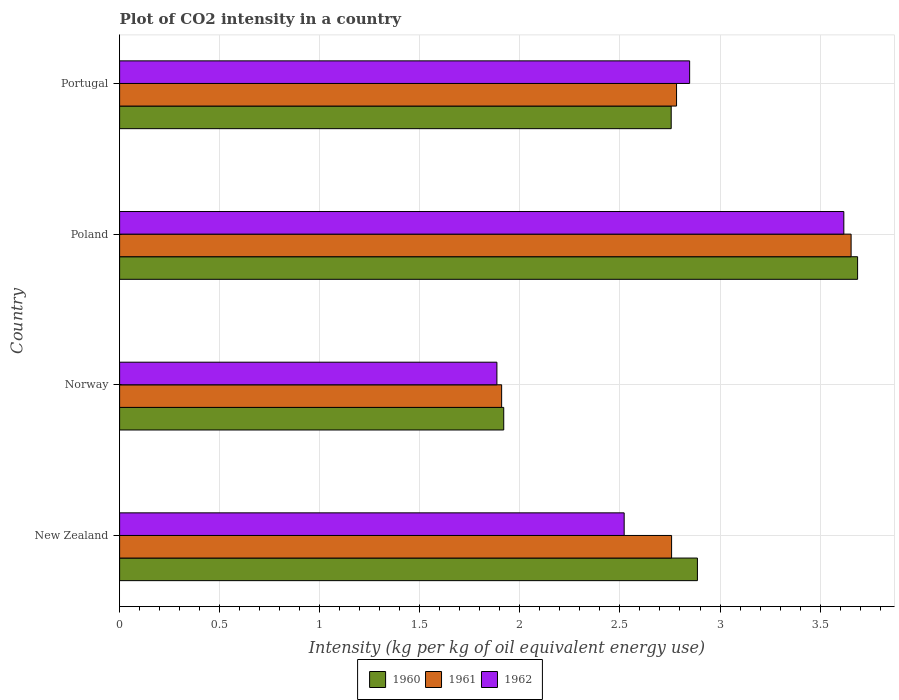How many groups of bars are there?
Ensure brevity in your answer.  4. Are the number of bars per tick equal to the number of legend labels?
Your answer should be compact. Yes. How many bars are there on the 3rd tick from the top?
Make the answer very short. 3. How many bars are there on the 3rd tick from the bottom?
Ensure brevity in your answer.  3. What is the label of the 4th group of bars from the top?
Your response must be concise. New Zealand. What is the CO2 intensity in in 1962 in Norway?
Keep it short and to the point. 1.89. Across all countries, what is the maximum CO2 intensity in in 1961?
Make the answer very short. 3.66. Across all countries, what is the minimum CO2 intensity in in 1961?
Provide a short and direct response. 1.91. In which country was the CO2 intensity in in 1962 maximum?
Your response must be concise. Poland. What is the total CO2 intensity in in 1961 in the graph?
Offer a terse response. 11.1. What is the difference between the CO2 intensity in in 1961 in Norway and that in Poland?
Provide a short and direct response. -1.75. What is the difference between the CO2 intensity in in 1962 in Poland and the CO2 intensity in in 1961 in Portugal?
Offer a very short reply. 0.84. What is the average CO2 intensity in in 1960 per country?
Your answer should be compact. 2.81. What is the difference between the CO2 intensity in in 1960 and CO2 intensity in in 1961 in Norway?
Offer a terse response. 0.01. In how many countries, is the CO2 intensity in in 1960 greater than 2.3 kg?
Keep it short and to the point. 3. What is the ratio of the CO2 intensity in in 1962 in New Zealand to that in Norway?
Provide a short and direct response. 1.34. Is the CO2 intensity in in 1962 in Norway less than that in Poland?
Keep it short and to the point. Yes. What is the difference between the highest and the second highest CO2 intensity in in 1960?
Offer a terse response. 0.8. What is the difference between the highest and the lowest CO2 intensity in in 1961?
Offer a terse response. 1.75. How many bars are there?
Provide a succinct answer. 12. Are all the bars in the graph horizontal?
Offer a very short reply. Yes. How many countries are there in the graph?
Keep it short and to the point. 4. Are the values on the major ticks of X-axis written in scientific E-notation?
Your response must be concise. No. Does the graph contain any zero values?
Make the answer very short. No. Does the graph contain grids?
Make the answer very short. Yes. How are the legend labels stacked?
Your answer should be compact. Horizontal. What is the title of the graph?
Provide a short and direct response. Plot of CO2 intensity in a country. Does "1984" appear as one of the legend labels in the graph?
Ensure brevity in your answer.  No. What is the label or title of the X-axis?
Provide a succinct answer. Intensity (kg per kg of oil equivalent energy use). What is the label or title of the Y-axis?
Offer a terse response. Country. What is the Intensity (kg per kg of oil equivalent energy use) of 1960 in New Zealand?
Offer a terse response. 2.89. What is the Intensity (kg per kg of oil equivalent energy use) of 1961 in New Zealand?
Provide a succinct answer. 2.76. What is the Intensity (kg per kg of oil equivalent energy use) of 1962 in New Zealand?
Your answer should be compact. 2.52. What is the Intensity (kg per kg of oil equivalent energy use) in 1960 in Norway?
Your answer should be compact. 1.92. What is the Intensity (kg per kg of oil equivalent energy use) of 1961 in Norway?
Ensure brevity in your answer.  1.91. What is the Intensity (kg per kg of oil equivalent energy use) in 1962 in Norway?
Offer a very short reply. 1.89. What is the Intensity (kg per kg of oil equivalent energy use) of 1960 in Poland?
Your answer should be very brief. 3.69. What is the Intensity (kg per kg of oil equivalent energy use) in 1961 in Poland?
Ensure brevity in your answer.  3.66. What is the Intensity (kg per kg of oil equivalent energy use) of 1962 in Poland?
Offer a terse response. 3.62. What is the Intensity (kg per kg of oil equivalent energy use) in 1960 in Portugal?
Give a very brief answer. 2.76. What is the Intensity (kg per kg of oil equivalent energy use) in 1961 in Portugal?
Your answer should be very brief. 2.78. What is the Intensity (kg per kg of oil equivalent energy use) of 1962 in Portugal?
Your answer should be compact. 2.85. Across all countries, what is the maximum Intensity (kg per kg of oil equivalent energy use) of 1960?
Make the answer very short. 3.69. Across all countries, what is the maximum Intensity (kg per kg of oil equivalent energy use) in 1961?
Offer a terse response. 3.66. Across all countries, what is the maximum Intensity (kg per kg of oil equivalent energy use) in 1962?
Your response must be concise. 3.62. Across all countries, what is the minimum Intensity (kg per kg of oil equivalent energy use) in 1960?
Your response must be concise. 1.92. Across all countries, what is the minimum Intensity (kg per kg of oil equivalent energy use) of 1961?
Provide a succinct answer. 1.91. Across all countries, what is the minimum Intensity (kg per kg of oil equivalent energy use) of 1962?
Keep it short and to the point. 1.89. What is the total Intensity (kg per kg of oil equivalent energy use) of 1960 in the graph?
Provide a short and direct response. 11.25. What is the total Intensity (kg per kg of oil equivalent energy use) in 1961 in the graph?
Provide a short and direct response. 11.1. What is the total Intensity (kg per kg of oil equivalent energy use) of 1962 in the graph?
Keep it short and to the point. 10.87. What is the difference between the Intensity (kg per kg of oil equivalent energy use) of 1960 in New Zealand and that in Norway?
Keep it short and to the point. 0.97. What is the difference between the Intensity (kg per kg of oil equivalent energy use) in 1961 in New Zealand and that in Norway?
Your answer should be compact. 0.85. What is the difference between the Intensity (kg per kg of oil equivalent energy use) in 1962 in New Zealand and that in Norway?
Your response must be concise. 0.64. What is the difference between the Intensity (kg per kg of oil equivalent energy use) of 1960 in New Zealand and that in Poland?
Ensure brevity in your answer.  -0.8. What is the difference between the Intensity (kg per kg of oil equivalent energy use) of 1961 in New Zealand and that in Poland?
Offer a terse response. -0.9. What is the difference between the Intensity (kg per kg of oil equivalent energy use) in 1962 in New Zealand and that in Poland?
Your answer should be compact. -1.1. What is the difference between the Intensity (kg per kg of oil equivalent energy use) in 1960 in New Zealand and that in Portugal?
Provide a succinct answer. 0.13. What is the difference between the Intensity (kg per kg of oil equivalent energy use) of 1961 in New Zealand and that in Portugal?
Make the answer very short. -0.02. What is the difference between the Intensity (kg per kg of oil equivalent energy use) of 1962 in New Zealand and that in Portugal?
Your response must be concise. -0.33. What is the difference between the Intensity (kg per kg of oil equivalent energy use) in 1960 in Norway and that in Poland?
Offer a terse response. -1.77. What is the difference between the Intensity (kg per kg of oil equivalent energy use) in 1961 in Norway and that in Poland?
Ensure brevity in your answer.  -1.75. What is the difference between the Intensity (kg per kg of oil equivalent energy use) of 1962 in Norway and that in Poland?
Keep it short and to the point. -1.73. What is the difference between the Intensity (kg per kg of oil equivalent energy use) in 1960 in Norway and that in Portugal?
Provide a succinct answer. -0.84. What is the difference between the Intensity (kg per kg of oil equivalent energy use) of 1961 in Norway and that in Portugal?
Your response must be concise. -0.87. What is the difference between the Intensity (kg per kg of oil equivalent energy use) in 1962 in Norway and that in Portugal?
Provide a succinct answer. -0.96. What is the difference between the Intensity (kg per kg of oil equivalent energy use) in 1960 in Poland and that in Portugal?
Offer a terse response. 0.93. What is the difference between the Intensity (kg per kg of oil equivalent energy use) in 1961 in Poland and that in Portugal?
Keep it short and to the point. 0.87. What is the difference between the Intensity (kg per kg of oil equivalent energy use) of 1962 in Poland and that in Portugal?
Make the answer very short. 0.77. What is the difference between the Intensity (kg per kg of oil equivalent energy use) in 1960 in New Zealand and the Intensity (kg per kg of oil equivalent energy use) in 1961 in Norway?
Provide a succinct answer. 0.98. What is the difference between the Intensity (kg per kg of oil equivalent energy use) of 1961 in New Zealand and the Intensity (kg per kg of oil equivalent energy use) of 1962 in Norway?
Keep it short and to the point. 0.87. What is the difference between the Intensity (kg per kg of oil equivalent energy use) in 1960 in New Zealand and the Intensity (kg per kg of oil equivalent energy use) in 1961 in Poland?
Your response must be concise. -0.77. What is the difference between the Intensity (kg per kg of oil equivalent energy use) of 1960 in New Zealand and the Intensity (kg per kg of oil equivalent energy use) of 1962 in Poland?
Keep it short and to the point. -0.73. What is the difference between the Intensity (kg per kg of oil equivalent energy use) in 1961 in New Zealand and the Intensity (kg per kg of oil equivalent energy use) in 1962 in Poland?
Your response must be concise. -0.86. What is the difference between the Intensity (kg per kg of oil equivalent energy use) in 1960 in New Zealand and the Intensity (kg per kg of oil equivalent energy use) in 1961 in Portugal?
Provide a short and direct response. 0.1. What is the difference between the Intensity (kg per kg of oil equivalent energy use) in 1960 in New Zealand and the Intensity (kg per kg of oil equivalent energy use) in 1962 in Portugal?
Ensure brevity in your answer.  0.04. What is the difference between the Intensity (kg per kg of oil equivalent energy use) in 1961 in New Zealand and the Intensity (kg per kg of oil equivalent energy use) in 1962 in Portugal?
Provide a short and direct response. -0.09. What is the difference between the Intensity (kg per kg of oil equivalent energy use) in 1960 in Norway and the Intensity (kg per kg of oil equivalent energy use) in 1961 in Poland?
Offer a very short reply. -1.74. What is the difference between the Intensity (kg per kg of oil equivalent energy use) of 1960 in Norway and the Intensity (kg per kg of oil equivalent energy use) of 1962 in Poland?
Provide a short and direct response. -1.7. What is the difference between the Intensity (kg per kg of oil equivalent energy use) of 1961 in Norway and the Intensity (kg per kg of oil equivalent energy use) of 1962 in Poland?
Your answer should be very brief. -1.71. What is the difference between the Intensity (kg per kg of oil equivalent energy use) in 1960 in Norway and the Intensity (kg per kg of oil equivalent energy use) in 1961 in Portugal?
Your answer should be very brief. -0.86. What is the difference between the Intensity (kg per kg of oil equivalent energy use) of 1960 in Norway and the Intensity (kg per kg of oil equivalent energy use) of 1962 in Portugal?
Your answer should be compact. -0.93. What is the difference between the Intensity (kg per kg of oil equivalent energy use) of 1961 in Norway and the Intensity (kg per kg of oil equivalent energy use) of 1962 in Portugal?
Provide a short and direct response. -0.94. What is the difference between the Intensity (kg per kg of oil equivalent energy use) in 1960 in Poland and the Intensity (kg per kg of oil equivalent energy use) in 1961 in Portugal?
Ensure brevity in your answer.  0.9. What is the difference between the Intensity (kg per kg of oil equivalent energy use) in 1960 in Poland and the Intensity (kg per kg of oil equivalent energy use) in 1962 in Portugal?
Offer a terse response. 0.84. What is the difference between the Intensity (kg per kg of oil equivalent energy use) in 1961 in Poland and the Intensity (kg per kg of oil equivalent energy use) in 1962 in Portugal?
Keep it short and to the point. 0.81. What is the average Intensity (kg per kg of oil equivalent energy use) in 1960 per country?
Your response must be concise. 2.81. What is the average Intensity (kg per kg of oil equivalent energy use) in 1961 per country?
Your answer should be very brief. 2.78. What is the average Intensity (kg per kg of oil equivalent energy use) of 1962 per country?
Give a very brief answer. 2.72. What is the difference between the Intensity (kg per kg of oil equivalent energy use) of 1960 and Intensity (kg per kg of oil equivalent energy use) of 1961 in New Zealand?
Provide a short and direct response. 0.13. What is the difference between the Intensity (kg per kg of oil equivalent energy use) in 1960 and Intensity (kg per kg of oil equivalent energy use) in 1962 in New Zealand?
Make the answer very short. 0.37. What is the difference between the Intensity (kg per kg of oil equivalent energy use) in 1961 and Intensity (kg per kg of oil equivalent energy use) in 1962 in New Zealand?
Your answer should be compact. 0.24. What is the difference between the Intensity (kg per kg of oil equivalent energy use) in 1960 and Intensity (kg per kg of oil equivalent energy use) in 1961 in Norway?
Offer a very short reply. 0.01. What is the difference between the Intensity (kg per kg of oil equivalent energy use) of 1960 and Intensity (kg per kg of oil equivalent energy use) of 1962 in Norway?
Provide a succinct answer. 0.03. What is the difference between the Intensity (kg per kg of oil equivalent energy use) of 1961 and Intensity (kg per kg of oil equivalent energy use) of 1962 in Norway?
Provide a short and direct response. 0.02. What is the difference between the Intensity (kg per kg of oil equivalent energy use) in 1960 and Intensity (kg per kg of oil equivalent energy use) in 1961 in Poland?
Offer a terse response. 0.03. What is the difference between the Intensity (kg per kg of oil equivalent energy use) in 1960 and Intensity (kg per kg of oil equivalent energy use) in 1962 in Poland?
Make the answer very short. 0.07. What is the difference between the Intensity (kg per kg of oil equivalent energy use) in 1961 and Intensity (kg per kg of oil equivalent energy use) in 1962 in Poland?
Provide a short and direct response. 0.04. What is the difference between the Intensity (kg per kg of oil equivalent energy use) of 1960 and Intensity (kg per kg of oil equivalent energy use) of 1961 in Portugal?
Provide a succinct answer. -0.03. What is the difference between the Intensity (kg per kg of oil equivalent energy use) in 1960 and Intensity (kg per kg of oil equivalent energy use) in 1962 in Portugal?
Offer a terse response. -0.09. What is the difference between the Intensity (kg per kg of oil equivalent energy use) in 1961 and Intensity (kg per kg of oil equivalent energy use) in 1962 in Portugal?
Your answer should be very brief. -0.07. What is the ratio of the Intensity (kg per kg of oil equivalent energy use) in 1960 in New Zealand to that in Norway?
Your response must be concise. 1.5. What is the ratio of the Intensity (kg per kg of oil equivalent energy use) in 1961 in New Zealand to that in Norway?
Offer a very short reply. 1.44. What is the ratio of the Intensity (kg per kg of oil equivalent energy use) in 1962 in New Zealand to that in Norway?
Give a very brief answer. 1.34. What is the ratio of the Intensity (kg per kg of oil equivalent energy use) of 1960 in New Zealand to that in Poland?
Your response must be concise. 0.78. What is the ratio of the Intensity (kg per kg of oil equivalent energy use) of 1961 in New Zealand to that in Poland?
Keep it short and to the point. 0.75. What is the ratio of the Intensity (kg per kg of oil equivalent energy use) of 1962 in New Zealand to that in Poland?
Provide a succinct answer. 0.7. What is the ratio of the Intensity (kg per kg of oil equivalent energy use) in 1960 in New Zealand to that in Portugal?
Offer a very short reply. 1.05. What is the ratio of the Intensity (kg per kg of oil equivalent energy use) in 1961 in New Zealand to that in Portugal?
Provide a short and direct response. 0.99. What is the ratio of the Intensity (kg per kg of oil equivalent energy use) in 1962 in New Zealand to that in Portugal?
Your answer should be very brief. 0.89. What is the ratio of the Intensity (kg per kg of oil equivalent energy use) of 1960 in Norway to that in Poland?
Provide a short and direct response. 0.52. What is the ratio of the Intensity (kg per kg of oil equivalent energy use) in 1961 in Norway to that in Poland?
Offer a terse response. 0.52. What is the ratio of the Intensity (kg per kg of oil equivalent energy use) of 1962 in Norway to that in Poland?
Offer a terse response. 0.52. What is the ratio of the Intensity (kg per kg of oil equivalent energy use) of 1960 in Norway to that in Portugal?
Keep it short and to the point. 0.7. What is the ratio of the Intensity (kg per kg of oil equivalent energy use) of 1961 in Norway to that in Portugal?
Ensure brevity in your answer.  0.69. What is the ratio of the Intensity (kg per kg of oil equivalent energy use) in 1962 in Norway to that in Portugal?
Your answer should be compact. 0.66. What is the ratio of the Intensity (kg per kg of oil equivalent energy use) in 1960 in Poland to that in Portugal?
Give a very brief answer. 1.34. What is the ratio of the Intensity (kg per kg of oil equivalent energy use) of 1961 in Poland to that in Portugal?
Make the answer very short. 1.31. What is the ratio of the Intensity (kg per kg of oil equivalent energy use) in 1962 in Poland to that in Portugal?
Ensure brevity in your answer.  1.27. What is the difference between the highest and the second highest Intensity (kg per kg of oil equivalent energy use) in 1960?
Your answer should be compact. 0.8. What is the difference between the highest and the second highest Intensity (kg per kg of oil equivalent energy use) in 1961?
Offer a terse response. 0.87. What is the difference between the highest and the second highest Intensity (kg per kg of oil equivalent energy use) of 1962?
Keep it short and to the point. 0.77. What is the difference between the highest and the lowest Intensity (kg per kg of oil equivalent energy use) of 1960?
Make the answer very short. 1.77. What is the difference between the highest and the lowest Intensity (kg per kg of oil equivalent energy use) of 1961?
Make the answer very short. 1.75. What is the difference between the highest and the lowest Intensity (kg per kg of oil equivalent energy use) of 1962?
Your answer should be compact. 1.73. 